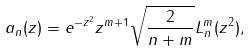Convert formula to latex. <formula><loc_0><loc_0><loc_500><loc_500>a _ { n } ( z ) = e ^ { - z ^ { 2 } } z ^ { m + 1 } \sqrt { \frac { 2 } { n + m } } L ^ { m } _ { n } ( z ^ { 2 } ) ,</formula> 